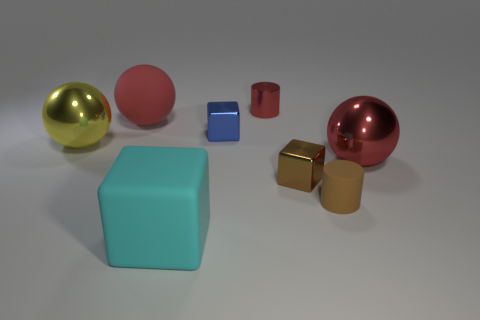How many things are either small blue metal cubes or large purple metallic objects?
Make the answer very short. 1. Is the material of the large red thing that is left of the small red shiny thing the same as the small block that is left of the metal cylinder?
Make the answer very short. No. There is a tiny cylinder that is the same material as the small blue object; what is its color?
Provide a short and direct response. Red. What number of blue metallic things have the same size as the red cylinder?
Give a very brief answer. 1. What number of other objects are the same color as the big rubber sphere?
Provide a short and direct response. 2. Do the large cyan matte object that is in front of the blue metal thing and the red object that is in front of the large yellow shiny object have the same shape?
Your response must be concise. No. The red shiny object that is the same size as the matte cylinder is what shape?
Give a very brief answer. Cylinder. Is the number of blue objects in front of the big yellow metallic sphere the same as the number of big red objects that are to the right of the tiny metal cylinder?
Ensure brevity in your answer.  No. Are there any other things that are the same shape as the large cyan object?
Ensure brevity in your answer.  Yes. Is the material of the cylinder that is in front of the brown metallic block the same as the big cyan cube?
Your answer should be very brief. Yes. 